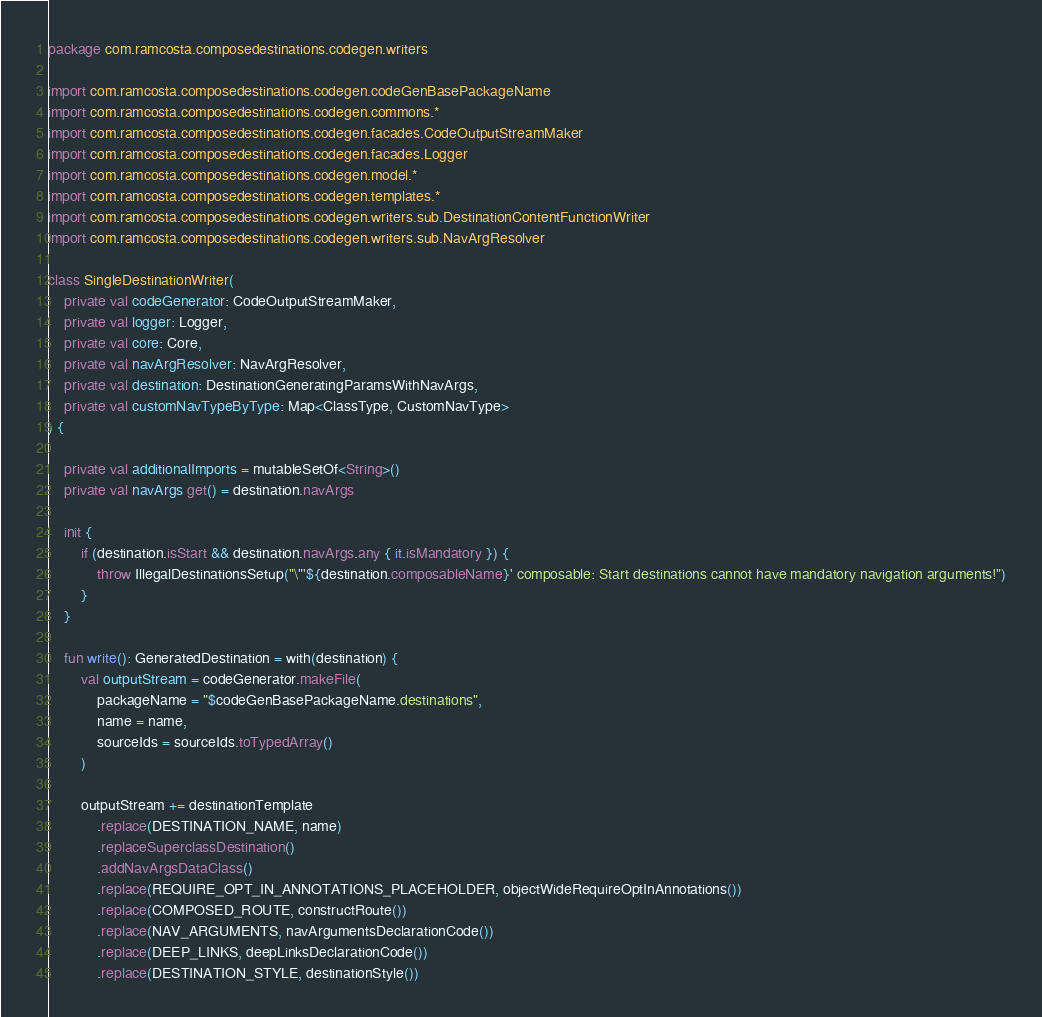Convert code to text. <code><loc_0><loc_0><loc_500><loc_500><_Kotlin_>package com.ramcosta.composedestinations.codegen.writers

import com.ramcosta.composedestinations.codegen.codeGenBasePackageName
import com.ramcosta.composedestinations.codegen.commons.*
import com.ramcosta.composedestinations.codegen.facades.CodeOutputStreamMaker
import com.ramcosta.composedestinations.codegen.facades.Logger
import com.ramcosta.composedestinations.codegen.model.*
import com.ramcosta.composedestinations.codegen.templates.*
import com.ramcosta.composedestinations.codegen.writers.sub.DestinationContentFunctionWriter
import com.ramcosta.composedestinations.codegen.writers.sub.NavArgResolver

class SingleDestinationWriter(
    private val codeGenerator: CodeOutputStreamMaker,
    private val logger: Logger,
    private val core: Core,
    private val navArgResolver: NavArgResolver,
    private val destination: DestinationGeneratingParamsWithNavArgs,
    private val customNavTypeByType: Map<ClassType, CustomNavType>
) {

    private val additionalImports = mutableSetOf<String>()
    private val navArgs get() = destination.navArgs

    init {
        if (destination.isStart && destination.navArgs.any { it.isMandatory }) {
            throw IllegalDestinationsSetup("\"'${destination.composableName}' composable: Start destinations cannot have mandatory navigation arguments!")
        }
    }

    fun write(): GeneratedDestination = with(destination) {
        val outputStream = codeGenerator.makeFile(
            packageName = "$codeGenBasePackageName.destinations",
            name = name,
            sourceIds = sourceIds.toTypedArray()
        )

        outputStream += destinationTemplate
            .replace(DESTINATION_NAME, name)
            .replaceSuperclassDestination()
            .addNavArgsDataClass()
            .replace(REQUIRE_OPT_IN_ANNOTATIONS_PLACEHOLDER, objectWideRequireOptInAnnotations())
            .replace(COMPOSED_ROUTE, constructRoute())
            .replace(NAV_ARGUMENTS, navArgumentsDeclarationCode())
            .replace(DEEP_LINKS, deepLinksDeclarationCode())
            .replace(DESTINATION_STYLE, destinationStyle())</code> 